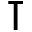<formula> <loc_0><loc_0><loc_500><loc_500>\intercal</formula> 